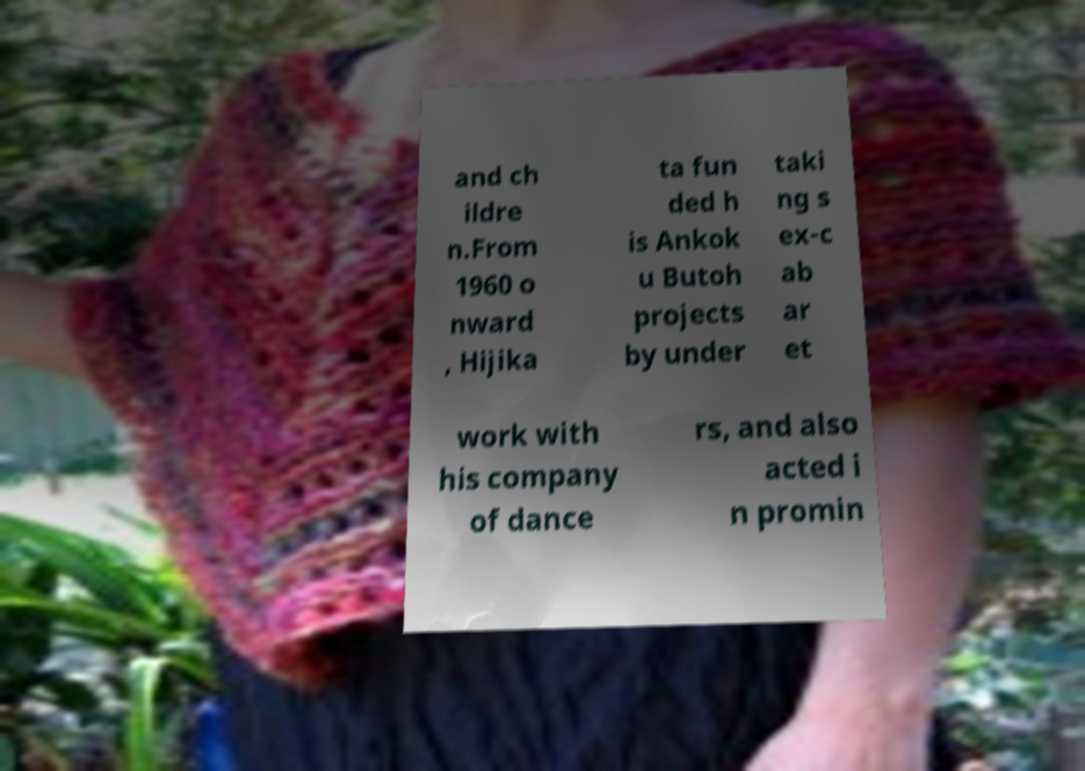Could you assist in decoding the text presented in this image and type it out clearly? and ch ildre n.From 1960 o nward , Hijika ta fun ded h is Ankok u Butoh projects by under taki ng s ex-c ab ar et work with his company of dance rs, and also acted i n promin 